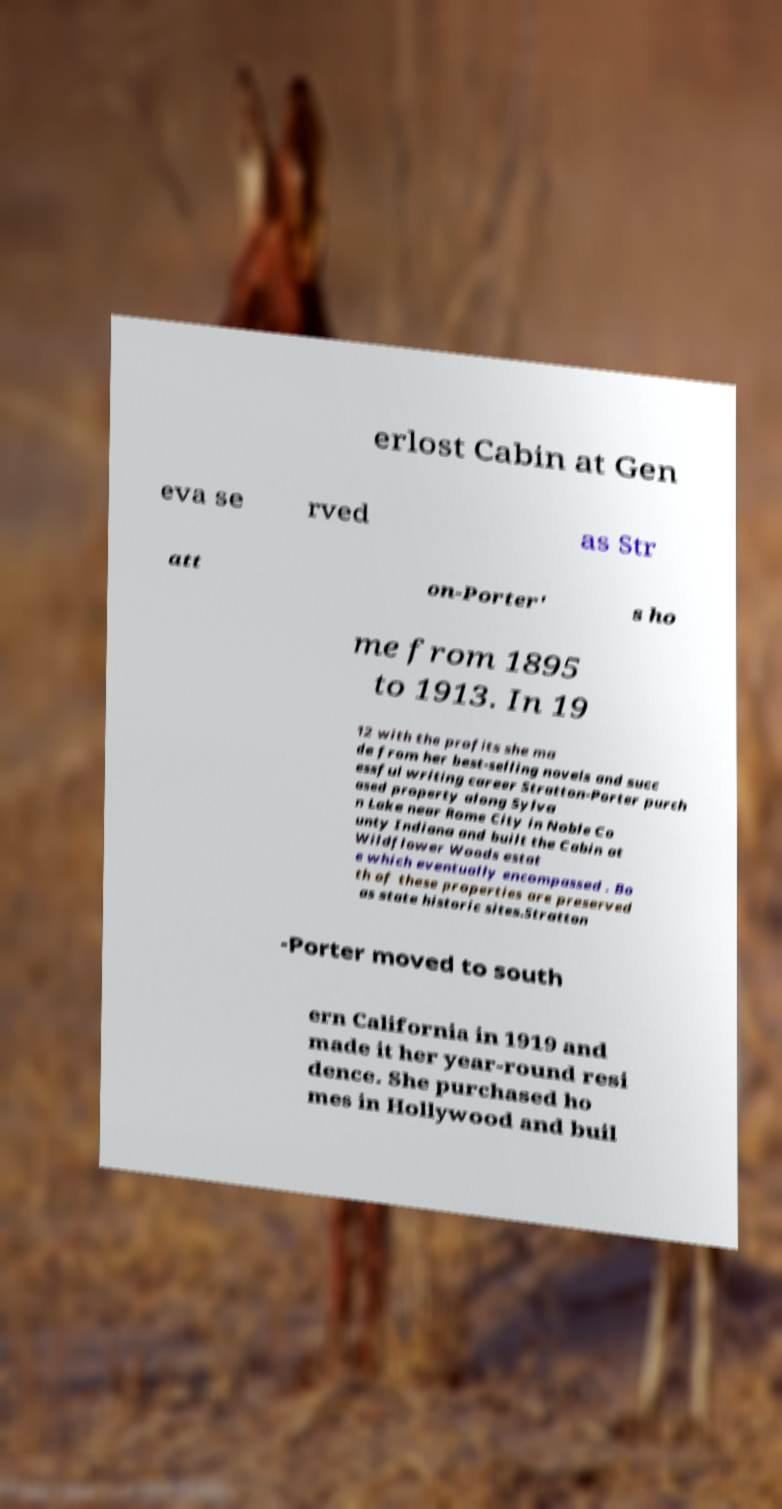Can you accurately transcribe the text from the provided image for me? erlost Cabin at Gen eva se rved as Str att on-Porter' s ho me from 1895 to 1913. In 19 12 with the profits she ma de from her best-selling novels and succ essful writing career Stratton-Porter purch ased property along Sylva n Lake near Rome City in Noble Co unty Indiana and built the Cabin at Wildflower Woods estat e which eventually encompassed . Bo th of these properties are preserved as state historic sites.Stratton -Porter moved to south ern California in 1919 and made it her year-round resi dence. She purchased ho mes in Hollywood and buil 